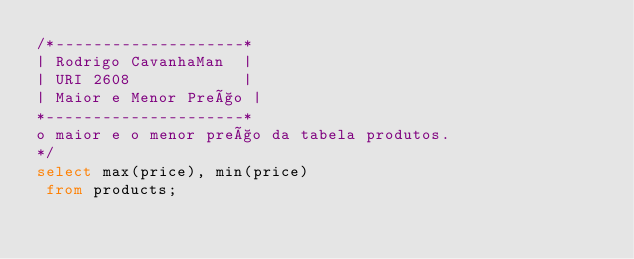<code> <loc_0><loc_0><loc_500><loc_500><_SQL_>/*--------------------*
| Rodrigo CavanhaMan  |
| URI 2608            |
| Maior e Menor Preço |
*---------------------*
o maior e o menor preço da tabela produtos.
*/
select max(price), min(price)
 from products;</code> 